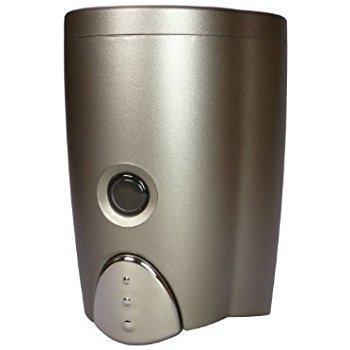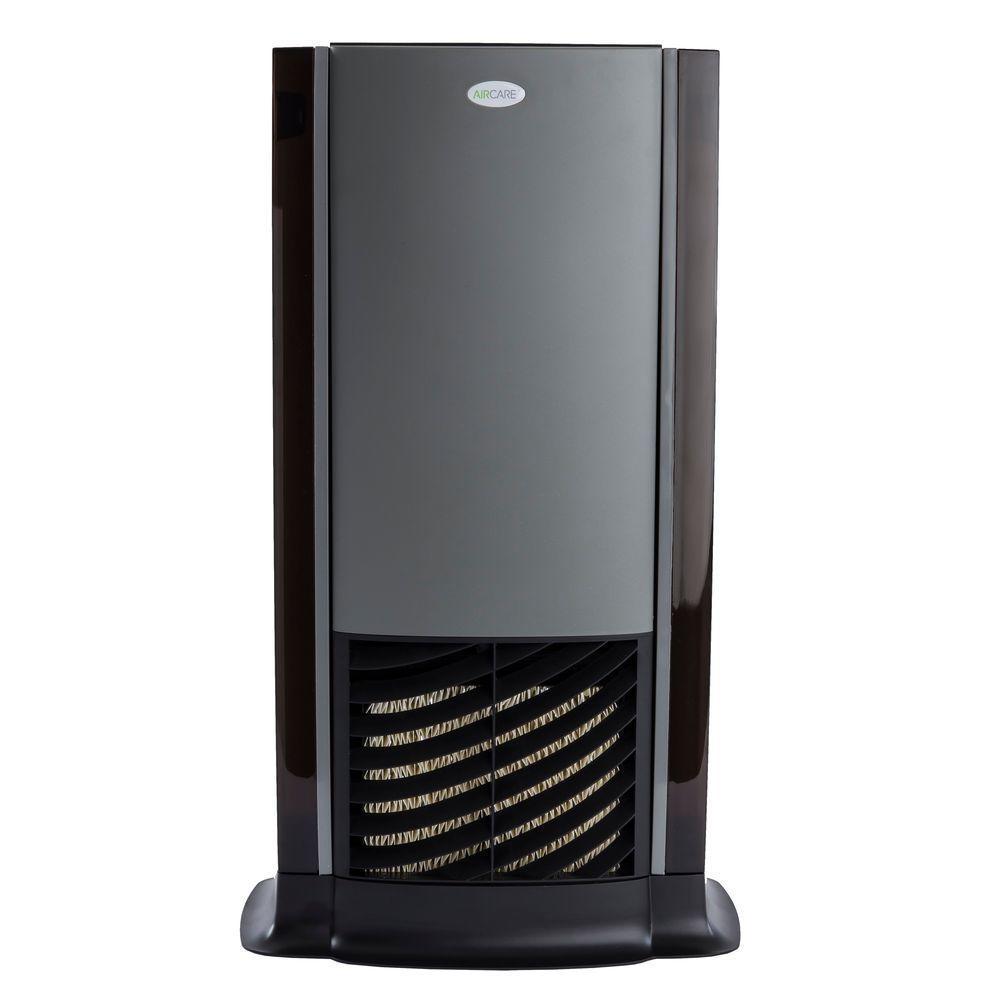The first image is the image on the left, the second image is the image on the right. For the images shown, is this caption "The dispenser on the right has a black base." true? Answer yes or no. Yes. 